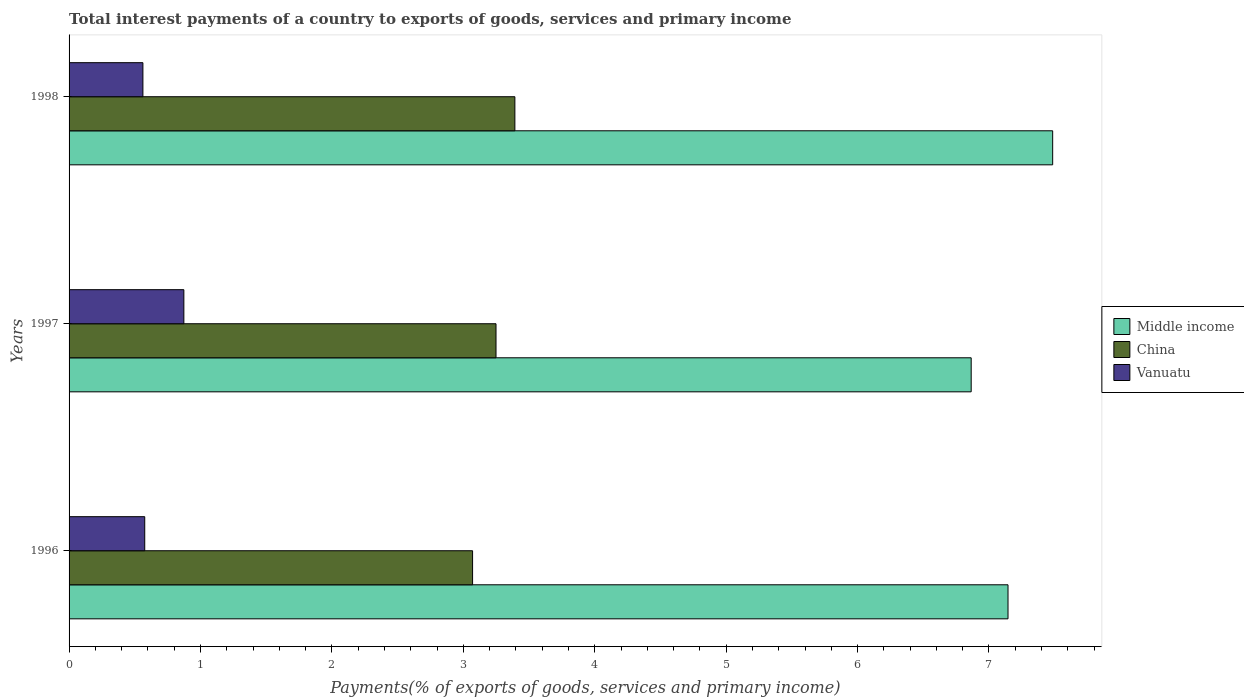How many different coloured bars are there?
Your answer should be very brief. 3. Are the number of bars per tick equal to the number of legend labels?
Provide a succinct answer. Yes. Are the number of bars on each tick of the Y-axis equal?
Provide a short and direct response. Yes. How many bars are there on the 2nd tick from the bottom?
Your response must be concise. 3. In how many cases, is the number of bars for a given year not equal to the number of legend labels?
Provide a succinct answer. 0. What is the total interest payments in China in 1996?
Offer a terse response. 3.07. Across all years, what is the maximum total interest payments in Vanuatu?
Ensure brevity in your answer.  0.87. Across all years, what is the minimum total interest payments in Vanuatu?
Your answer should be very brief. 0.56. What is the total total interest payments in China in the graph?
Keep it short and to the point. 9.71. What is the difference between the total interest payments in China in 1997 and that in 1998?
Offer a very short reply. -0.14. What is the difference between the total interest payments in Middle income in 1996 and the total interest payments in China in 1997?
Your answer should be very brief. 3.9. What is the average total interest payments in Vanuatu per year?
Make the answer very short. 0.67. In the year 1997, what is the difference between the total interest payments in Vanuatu and total interest payments in China?
Keep it short and to the point. -2.38. What is the ratio of the total interest payments in Middle income in 1997 to that in 1998?
Provide a short and direct response. 0.92. Is the total interest payments in Middle income in 1997 less than that in 1998?
Your answer should be very brief. Yes. Is the difference between the total interest payments in Vanuatu in 1997 and 1998 greater than the difference between the total interest payments in China in 1997 and 1998?
Provide a succinct answer. Yes. What is the difference between the highest and the second highest total interest payments in China?
Your answer should be very brief. 0.14. What is the difference between the highest and the lowest total interest payments in Middle income?
Make the answer very short. 0.62. In how many years, is the total interest payments in Middle income greater than the average total interest payments in Middle income taken over all years?
Offer a terse response. 1. Is the sum of the total interest payments in China in 1997 and 1998 greater than the maximum total interest payments in Vanuatu across all years?
Provide a succinct answer. Yes. What does the 1st bar from the top in 1998 represents?
Your response must be concise. Vanuatu. What does the 3rd bar from the bottom in 1998 represents?
Give a very brief answer. Vanuatu. Is it the case that in every year, the sum of the total interest payments in Vanuatu and total interest payments in China is greater than the total interest payments in Middle income?
Your response must be concise. No. How many bars are there?
Provide a short and direct response. 9. Are all the bars in the graph horizontal?
Give a very brief answer. Yes. How many years are there in the graph?
Provide a succinct answer. 3. What is the difference between two consecutive major ticks on the X-axis?
Ensure brevity in your answer.  1. Are the values on the major ticks of X-axis written in scientific E-notation?
Ensure brevity in your answer.  No. Does the graph contain any zero values?
Your response must be concise. No. Where does the legend appear in the graph?
Give a very brief answer. Center right. How many legend labels are there?
Provide a short and direct response. 3. How are the legend labels stacked?
Ensure brevity in your answer.  Vertical. What is the title of the graph?
Offer a very short reply. Total interest payments of a country to exports of goods, services and primary income. Does "Rwanda" appear as one of the legend labels in the graph?
Provide a succinct answer. No. What is the label or title of the X-axis?
Provide a succinct answer. Payments(% of exports of goods, services and primary income). What is the label or title of the Y-axis?
Ensure brevity in your answer.  Years. What is the Payments(% of exports of goods, services and primary income) in Middle income in 1996?
Give a very brief answer. 7.14. What is the Payments(% of exports of goods, services and primary income) of China in 1996?
Keep it short and to the point. 3.07. What is the Payments(% of exports of goods, services and primary income) in Vanuatu in 1996?
Provide a short and direct response. 0.58. What is the Payments(% of exports of goods, services and primary income) of Middle income in 1997?
Give a very brief answer. 6.86. What is the Payments(% of exports of goods, services and primary income) in China in 1997?
Give a very brief answer. 3.25. What is the Payments(% of exports of goods, services and primary income) in Vanuatu in 1997?
Offer a very short reply. 0.87. What is the Payments(% of exports of goods, services and primary income) in Middle income in 1998?
Ensure brevity in your answer.  7.48. What is the Payments(% of exports of goods, services and primary income) in China in 1998?
Provide a short and direct response. 3.39. What is the Payments(% of exports of goods, services and primary income) in Vanuatu in 1998?
Your answer should be compact. 0.56. Across all years, what is the maximum Payments(% of exports of goods, services and primary income) in Middle income?
Ensure brevity in your answer.  7.48. Across all years, what is the maximum Payments(% of exports of goods, services and primary income) in China?
Offer a very short reply. 3.39. Across all years, what is the maximum Payments(% of exports of goods, services and primary income) of Vanuatu?
Offer a terse response. 0.87. Across all years, what is the minimum Payments(% of exports of goods, services and primary income) in Middle income?
Provide a short and direct response. 6.86. Across all years, what is the minimum Payments(% of exports of goods, services and primary income) in China?
Offer a very short reply. 3.07. Across all years, what is the minimum Payments(% of exports of goods, services and primary income) in Vanuatu?
Provide a short and direct response. 0.56. What is the total Payments(% of exports of goods, services and primary income) in Middle income in the graph?
Offer a very short reply. 21.49. What is the total Payments(% of exports of goods, services and primary income) in China in the graph?
Offer a terse response. 9.71. What is the total Payments(% of exports of goods, services and primary income) of Vanuatu in the graph?
Make the answer very short. 2.01. What is the difference between the Payments(% of exports of goods, services and primary income) of Middle income in 1996 and that in 1997?
Offer a terse response. 0.28. What is the difference between the Payments(% of exports of goods, services and primary income) in China in 1996 and that in 1997?
Your answer should be very brief. -0.18. What is the difference between the Payments(% of exports of goods, services and primary income) of Vanuatu in 1996 and that in 1997?
Provide a short and direct response. -0.3. What is the difference between the Payments(% of exports of goods, services and primary income) in Middle income in 1996 and that in 1998?
Provide a short and direct response. -0.34. What is the difference between the Payments(% of exports of goods, services and primary income) of China in 1996 and that in 1998?
Provide a short and direct response. -0.32. What is the difference between the Payments(% of exports of goods, services and primary income) of Vanuatu in 1996 and that in 1998?
Provide a short and direct response. 0.01. What is the difference between the Payments(% of exports of goods, services and primary income) in Middle income in 1997 and that in 1998?
Keep it short and to the point. -0.62. What is the difference between the Payments(% of exports of goods, services and primary income) in China in 1997 and that in 1998?
Offer a terse response. -0.14. What is the difference between the Payments(% of exports of goods, services and primary income) of Vanuatu in 1997 and that in 1998?
Provide a succinct answer. 0.31. What is the difference between the Payments(% of exports of goods, services and primary income) in Middle income in 1996 and the Payments(% of exports of goods, services and primary income) in China in 1997?
Your answer should be compact. 3.9. What is the difference between the Payments(% of exports of goods, services and primary income) of Middle income in 1996 and the Payments(% of exports of goods, services and primary income) of Vanuatu in 1997?
Provide a short and direct response. 6.27. What is the difference between the Payments(% of exports of goods, services and primary income) of China in 1996 and the Payments(% of exports of goods, services and primary income) of Vanuatu in 1997?
Offer a terse response. 2.2. What is the difference between the Payments(% of exports of goods, services and primary income) of Middle income in 1996 and the Payments(% of exports of goods, services and primary income) of China in 1998?
Ensure brevity in your answer.  3.75. What is the difference between the Payments(% of exports of goods, services and primary income) of Middle income in 1996 and the Payments(% of exports of goods, services and primary income) of Vanuatu in 1998?
Your answer should be very brief. 6.58. What is the difference between the Payments(% of exports of goods, services and primary income) in China in 1996 and the Payments(% of exports of goods, services and primary income) in Vanuatu in 1998?
Your answer should be compact. 2.51. What is the difference between the Payments(% of exports of goods, services and primary income) in Middle income in 1997 and the Payments(% of exports of goods, services and primary income) in China in 1998?
Provide a succinct answer. 3.47. What is the difference between the Payments(% of exports of goods, services and primary income) in Middle income in 1997 and the Payments(% of exports of goods, services and primary income) in Vanuatu in 1998?
Give a very brief answer. 6.3. What is the difference between the Payments(% of exports of goods, services and primary income) in China in 1997 and the Payments(% of exports of goods, services and primary income) in Vanuatu in 1998?
Keep it short and to the point. 2.69. What is the average Payments(% of exports of goods, services and primary income) in Middle income per year?
Your response must be concise. 7.16. What is the average Payments(% of exports of goods, services and primary income) of China per year?
Make the answer very short. 3.24. What is the average Payments(% of exports of goods, services and primary income) in Vanuatu per year?
Ensure brevity in your answer.  0.67. In the year 1996, what is the difference between the Payments(% of exports of goods, services and primary income) in Middle income and Payments(% of exports of goods, services and primary income) in China?
Provide a short and direct response. 4.07. In the year 1996, what is the difference between the Payments(% of exports of goods, services and primary income) in Middle income and Payments(% of exports of goods, services and primary income) in Vanuatu?
Your response must be concise. 6.57. In the year 1996, what is the difference between the Payments(% of exports of goods, services and primary income) of China and Payments(% of exports of goods, services and primary income) of Vanuatu?
Offer a very short reply. 2.49. In the year 1997, what is the difference between the Payments(% of exports of goods, services and primary income) in Middle income and Payments(% of exports of goods, services and primary income) in China?
Make the answer very short. 3.62. In the year 1997, what is the difference between the Payments(% of exports of goods, services and primary income) in Middle income and Payments(% of exports of goods, services and primary income) in Vanuatu?
Keep it short and to the point. 5.99. In the year 1997, what is the difference between the Payments(% of exports of goods, services and primary income) of China and Payments(% of exports of goods, services and primary income) of Vanuatu?
Keep it short and to the point. 2.38. In the year 1998, what is the difference between the Payments(% of exports of goods, services and primary income) of Middle income and Payments(% of exports of goods, services and primary income) of China?
Your answer should be compact. 4.09. In the year 1998, what is the difference between the Payments(% of exports of goods, services and primary income) in Middle income and Payments(% of exports of goods, services and primary income) in Vanuatu?
Your answer should be compact. 6.92. In the year 1998, what is the difference between the Payments(% of exports of goods, services and primary income) in China and Payments(% of exports of goods, services and primary income) in Vanuatu?
Offer a very short reply. 2.83. What is the ratio of the Payments(% of exports of goods, services and primary income) in Middle income in 1996 to that in 1997?
Your response must be concise. 1.04. What is the ratio of the Payments(% of exports of goods, services and primary income) of China in 1996 to that in 1997?
Offer a terse response. 0.95. What is the ratio of the Payments(% of exports of goods, services and primary income) of Vanuatu in 1996 to that in 1997?
Your answer should be very brief. 0.66. What is the ratio of the Payments(% of exports of goods, services and primary income) of Middle income in 1996 to that in 1998?
Provide a succinct answer. 0.95. What is the ratio of the Payments(% of exports of goods, services and primary income) in China in 1996 to that in 1998?
Keep it short and to the point. 0.91. What is the ratio of the Payments(% of exports of goods, services and primary income) of Vanuatu in 1996 to that in 1998?
Offer a terse response. 1.02. What is the ratio of the Payments(% of exports of goods, services and primary income) of Middle income in 1997 to that in 1998?
Your answer should be compact. 0.92. What is the ratio of the Payments(% of exports of goods, services and primary income) in China in 1997 to that in 1998?
Ensure brevity in your answer.  0.96. What is the ratio of the Payments(% of exports of goods, services and primary income) of Vanuatu in 1997 to that in 1998?
Your answer should be very brief. 1.55. What is the difference between the highest and the second highest Payments(% of exports of goods, services and primary income) of Middle income?
Provide a short and direct response. 0.34. What is the difference between the highest and the second highest Payments(% of exports of goods, services and primary income) in China?
Your response must be concise. 0.14. What is the difference between the highest and the second highest Payments(% of exports of goods, services and primary income) of Vanuatu?
Your answer should be compact. 0.3. What is the difference between the highest and the lowest Payments(% of exports of goods, services and primary income) in Middle income?
Provide a short and direct response. 0.62. What is the difference between the highest and the lowest Payments(% of exports of goods, services and primary income) of China?
Offer a very short reply. 0.32. What is the difference between the highest and the lowest Payments(% of exports of goods, services and primary income) of Vanuatu?
Provide a short and direct response. 0.31. 